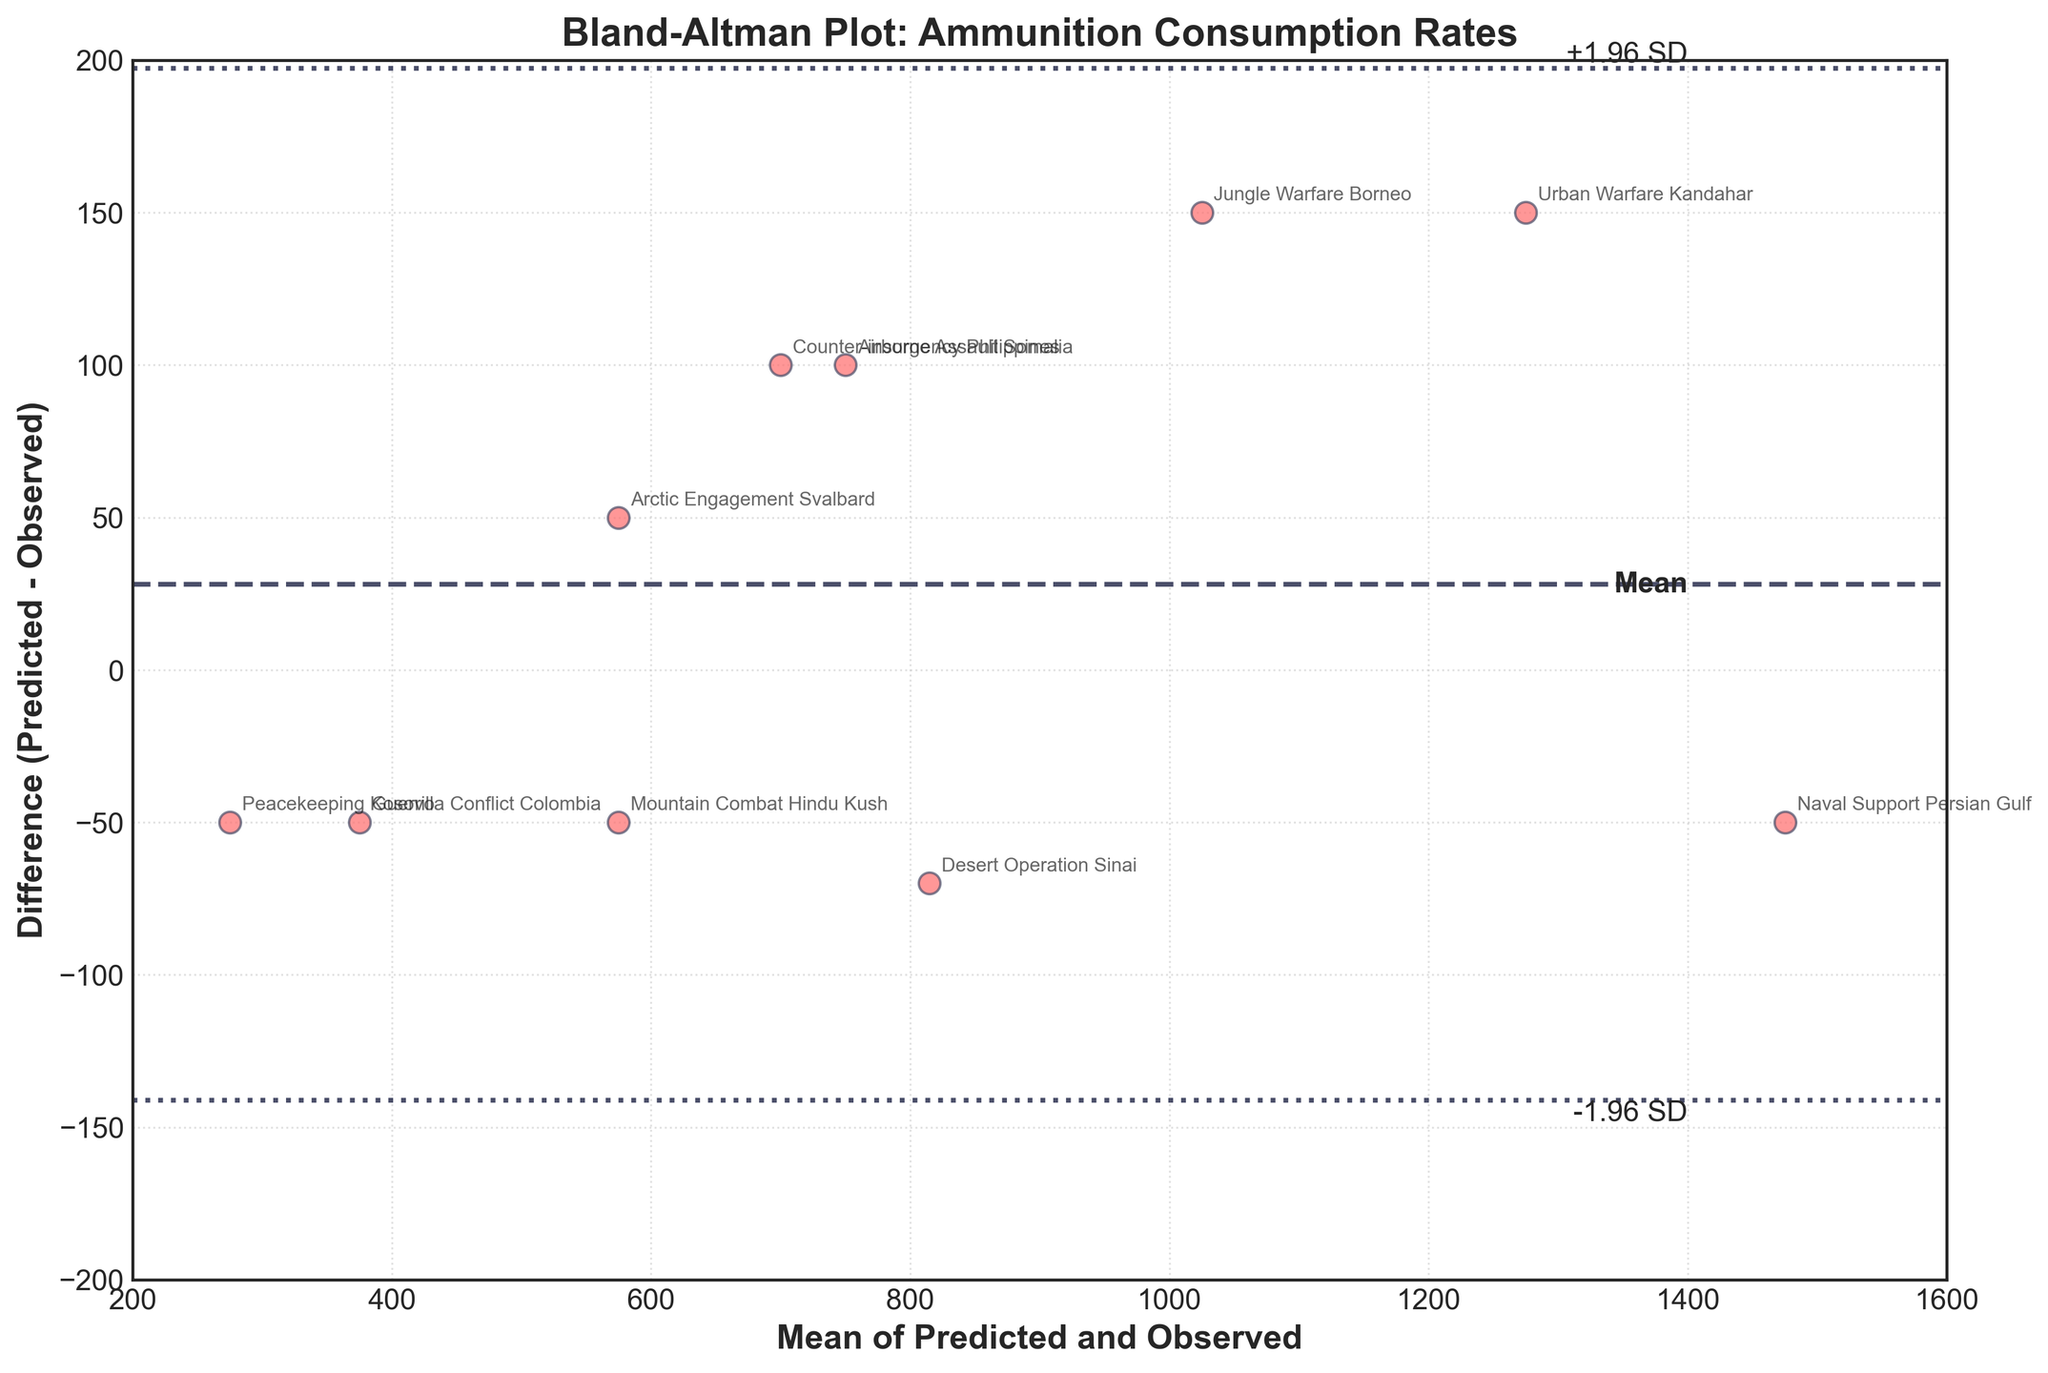What is the title of the figure? The title of the figure is typically displayed at the top of the plot, centrally aligned. The title here is "Bland-Altman Plot: Ammunition Consumption Rates".
Answer: Bland-Altman Plot: Ammunition Consumption Rates How many data points are shown in the plot? You can count the number of scatter points displayed in the plot. Each point corresponds to a combat scenario. There are 10 data points in total.
Answer: 10 What does the x-axis represent? The label on the x-axis usually indicates what it represents. In this figure, it is labeled as "Mean of Predicted and Observed", which shows the average of the predicted and observed values.
Answer: Mean of Predicted and Observed Which scenario has the highest mean value? By examining the x-axis, you can see the mean values plotted. The highest mean value aligns with the "Naval Support Persian Gulf" scenario, placed furthest to the right.
Answer: Naval Support Persian Gulf What is the mean difference of the differences in predicted and observed ammunition consumption rates? The mean difference is indicated by the center dashed line (mean line). This line labels the average difference of all points. The exact value is close to 0.
Answer: 0 Between which values do the ±1.96 SD lines fall? The ±1.96 SD lines indicate the range within which most differences fall. These lines are added and subtracted from the mean difference. Based on the plot, they fall around +100 and -100.
Answer: ±100 Which scenarios have a difference of exactly 150? You need to identify the points vertically aligned at the difference value of 150. The scenarios "Urban Warfare Kandahar" and "Jungle Warfare Borneo" match this difference.
Answer: Urban Warfare Kandahar, Jungle Warfare Borneo Which scenario has the largest negative difference, and what is its value? Look for the data point that is lowest on the plot in terms of difference. The "Desert Operation Sinai" scenario has the largest negative difference, which is -70.
Answer: Desert Operation Sinai, -70 Are there more positive or negative differences in the plot? Count the points above and below the mean difference line (0). There are 4 positive differences and 6 negative differences, which means there are more negative differences.
Answer: Negative differences 